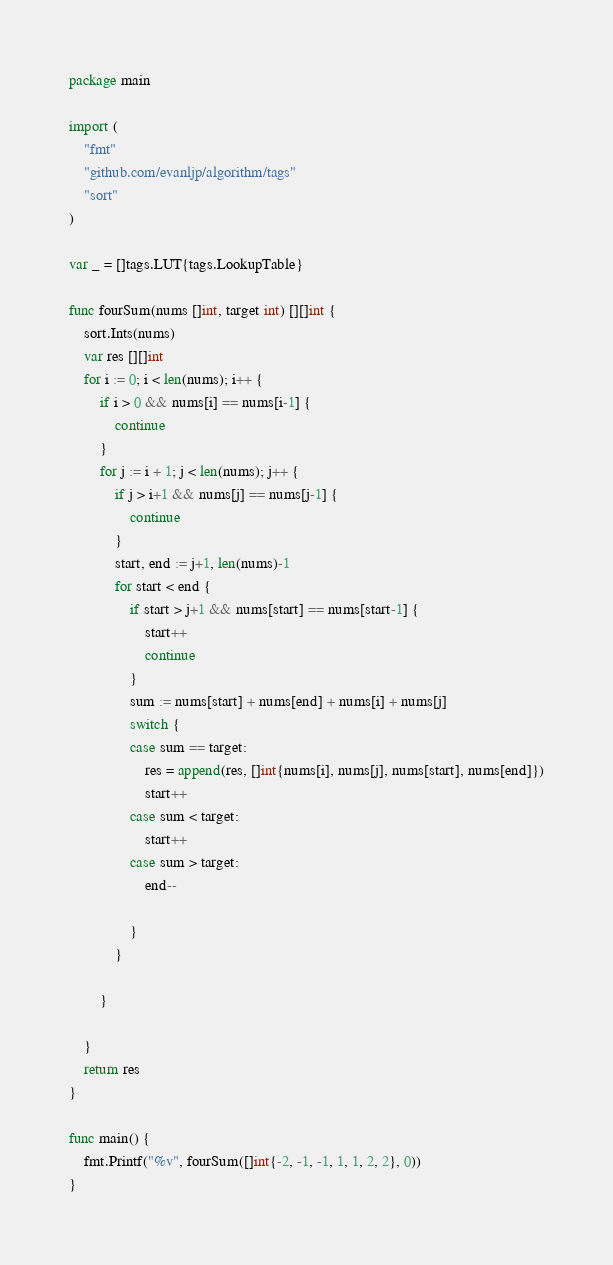Convert code to text. <code><loc_0><loc_0><loc_500><loc_500><_Go_>package main

import (
	"fmt"
	"github.com/evanljp/algorithm/tags"
	"sort"
)

var _ = []tags.LUT{tags.LookupTable}

func fourSum(nums []int, target int) [][]int {
	sort.Ints(nums)
	var res [][]int
	for i := 0; i < len(nums); i++ {
		if i > 0 && nums[i] == nums[i-1] {
			continue
		}
		for j := i + 1; j < len(nums); j++ {
			if j > i+1 && nums[j] == nums[j-1] {
				continue
			}
			start, end := j+1, len(nums)-1
			for start < end {
				if start > j+1 && nums[start] == nums[start-1] {
					start++
					continue
				}
				sum := nums[start] + nums[end] + nums[i] + nums[j]
				switch {
				case sum == target:
					res = append(res, []int{nums[i], nums[j], nums[start], nums[end]})
					start++
				case sum < target:
					start++
				case sum > target:
					end--

				}
			}

		}

	}
	return res
}

func main() {
	fmt.Printf("%v", fourSum([]int{-2, -1, -1, 1, 1, 2, 2}, 0))
}
</code> 